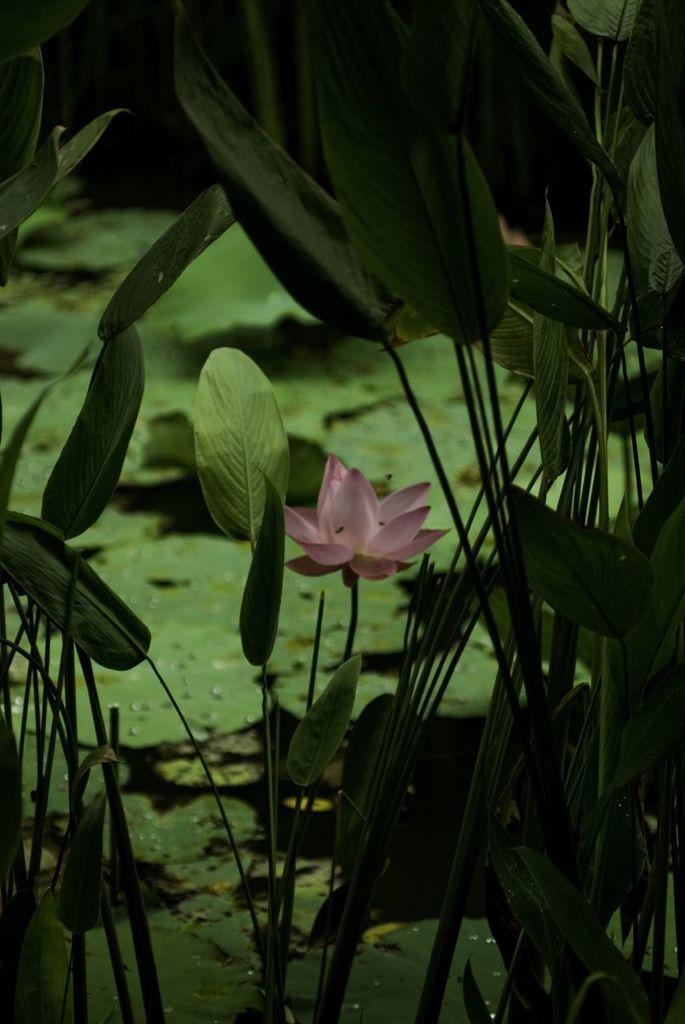How would you summarize this image in a sentence or two? We can see pink flower and green flowers. In the background we can see green leaves and it is dark. 